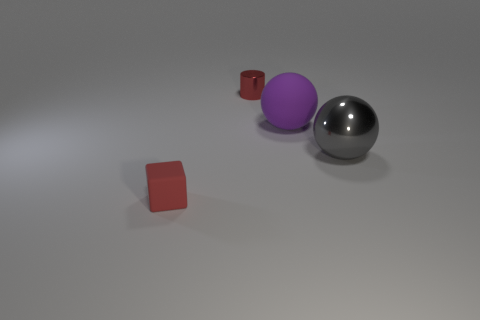Can you describe the texture of the objects? Certainly! The objects exhibit various textures: the gray sphere has a smooth, reflective metal surface, the purple sphere appears to be matte without any shine, and the two red cubes have a slightly rough texture that gives them a more diffuse reflection. Which object seems the most reflective? The most reflective object is the gray sphere, as it exhibits a mirror-like surface that clearly reflects the environment and the light, indicating a highly polished metallic material. 